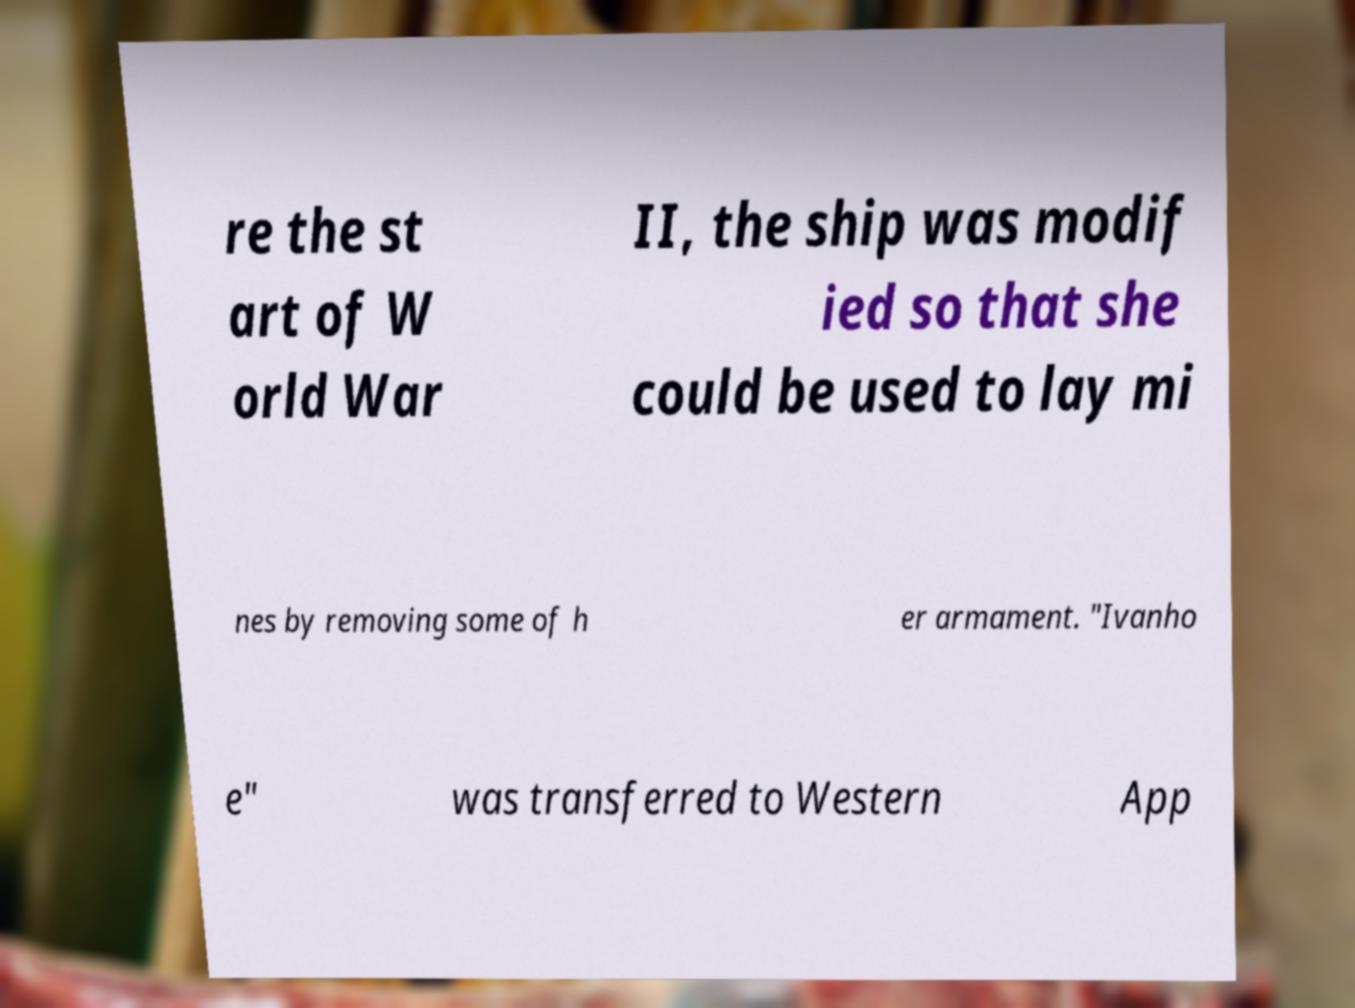Could you assist in decoding the text presented in this image and type it out clearly? re the st art of W orld War II, the ship was modif ied so that she could be used to lay mi nes by removing some of h er armament. "Ivanho e" was transferred to Western App 